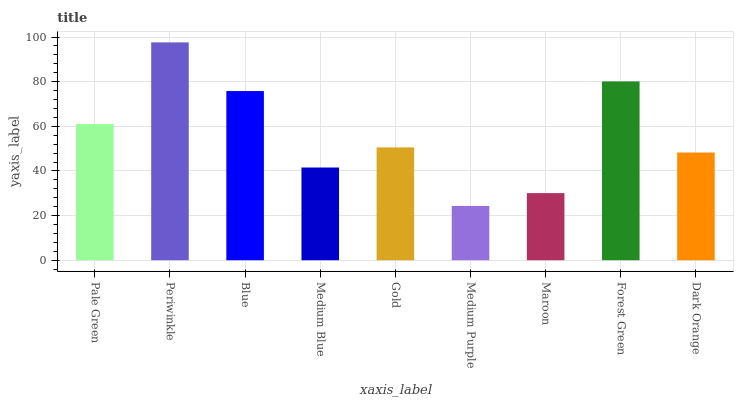Is Medium Purple the minimum?
Answer yes or no. Yes. Is Periwinkle the maximum?
Answer yes or no. Yes. Is Blue the minimum?
Answer yes or no. No. Is Blue the maximum?
Answer yes or no. No. Is Periwinkle greater than Blue?
Answer yes or no. Yes. Is Blue less than Periwinkle?
Answer yes or no. Yes. Is Blue greater than Periwinkle?
Answer yes or no. No. Is Periwinkle less than Blue?
Answer yes or no. No. Is Gold the high median?
Answer yes or no. Yes. Is Gold the low median?
Answer yes or no. Yes. Is Dark Orange the high median?
Answer yes or no. No. Is Forest Green the low median?
Answer yes or no. No. 